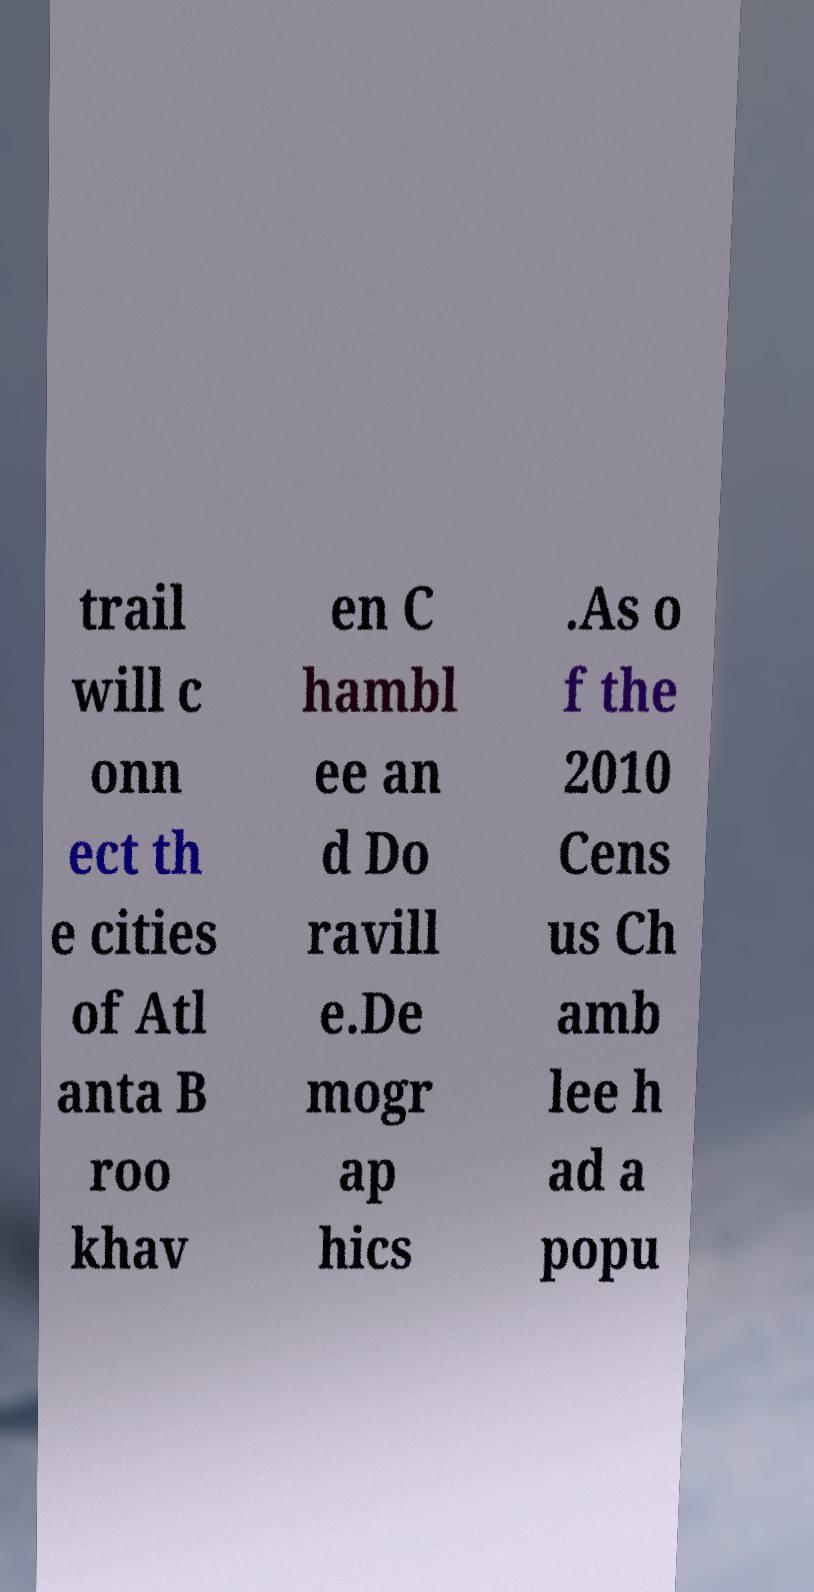Please identify and transcribe the text found in this image. trail will c onn ect th e cities of Atl anta B roo khav en C hambl ee an d Do ravill e.De mogr ap hics .As o f the 2010 Cens us Ch amb lee h ad a popu 